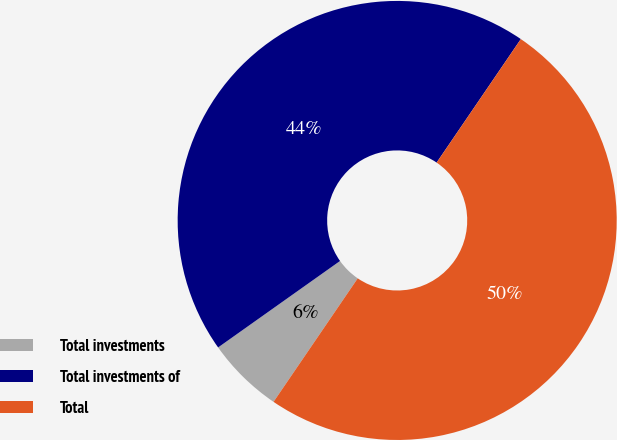Convert chart. <chart><loc_0><loc_0><loc_500><loc_500><pie_chart><fcel>Total investments<fcel>Total investments of<fcel>Total<nl><fcel>5.66%<fcel>44.34%<fcel>50.0%<nl></chart> 